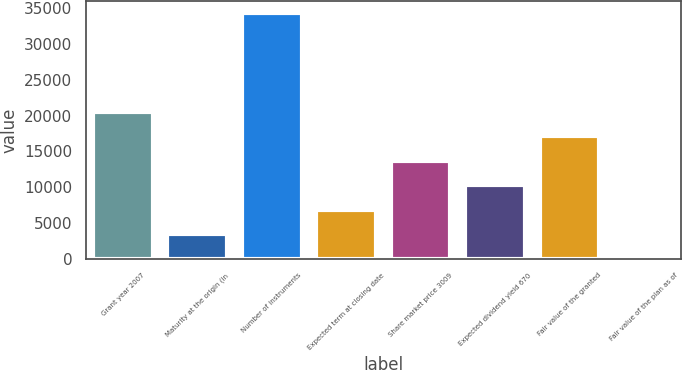Convert chart. <chart><loc_0><loc_0><loc_500><loc_500><bar_chart><fcel>Grant year 2007<fcel>Maturity at the origin (in<fcel>Number of instruments<fcel>Expected term at closing date<fcel>Share market price 3009<fcel>Expected dividend yield 670<fcel>Fair value of the granted<fcel>Fair value of the plan as of<nl><fcel>20534.8<fcel>3423.3<fcel>34224<fcel>6845.6<fcel>13690.2<fcel>10267.9<fcel>17112.5<fcel>1<nl></chart> 